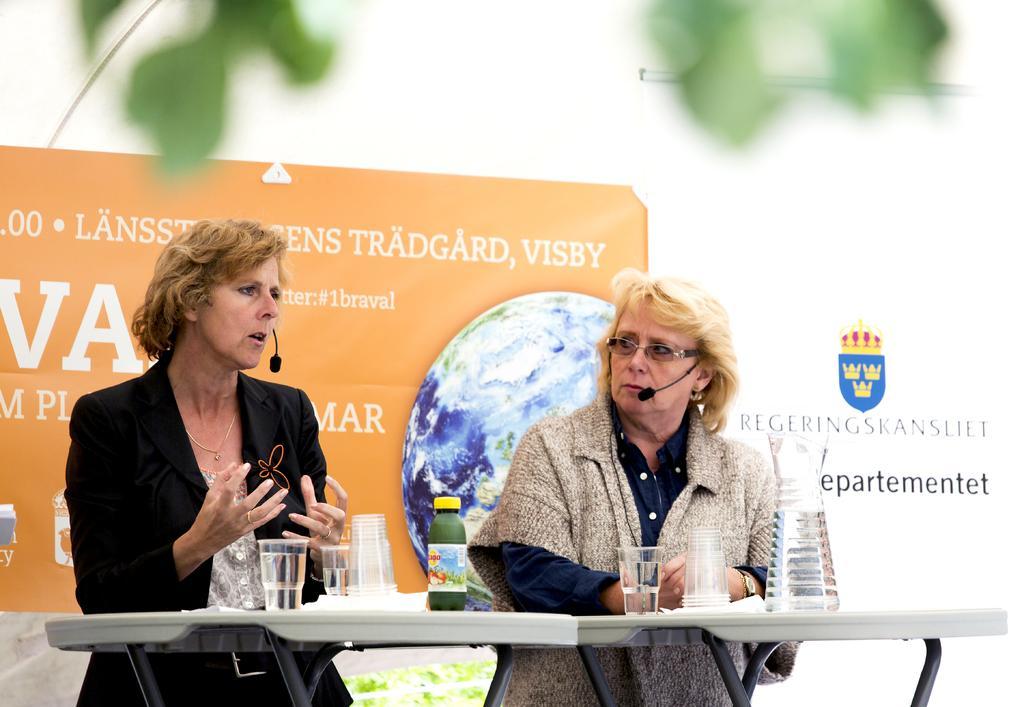Could you give a brief overview of what you see in this image? In this image I can see two persons with microphones. There are glasses with water and there are some other objects on the table. In the background it looks like a board and at the top of the image there are leaves. 